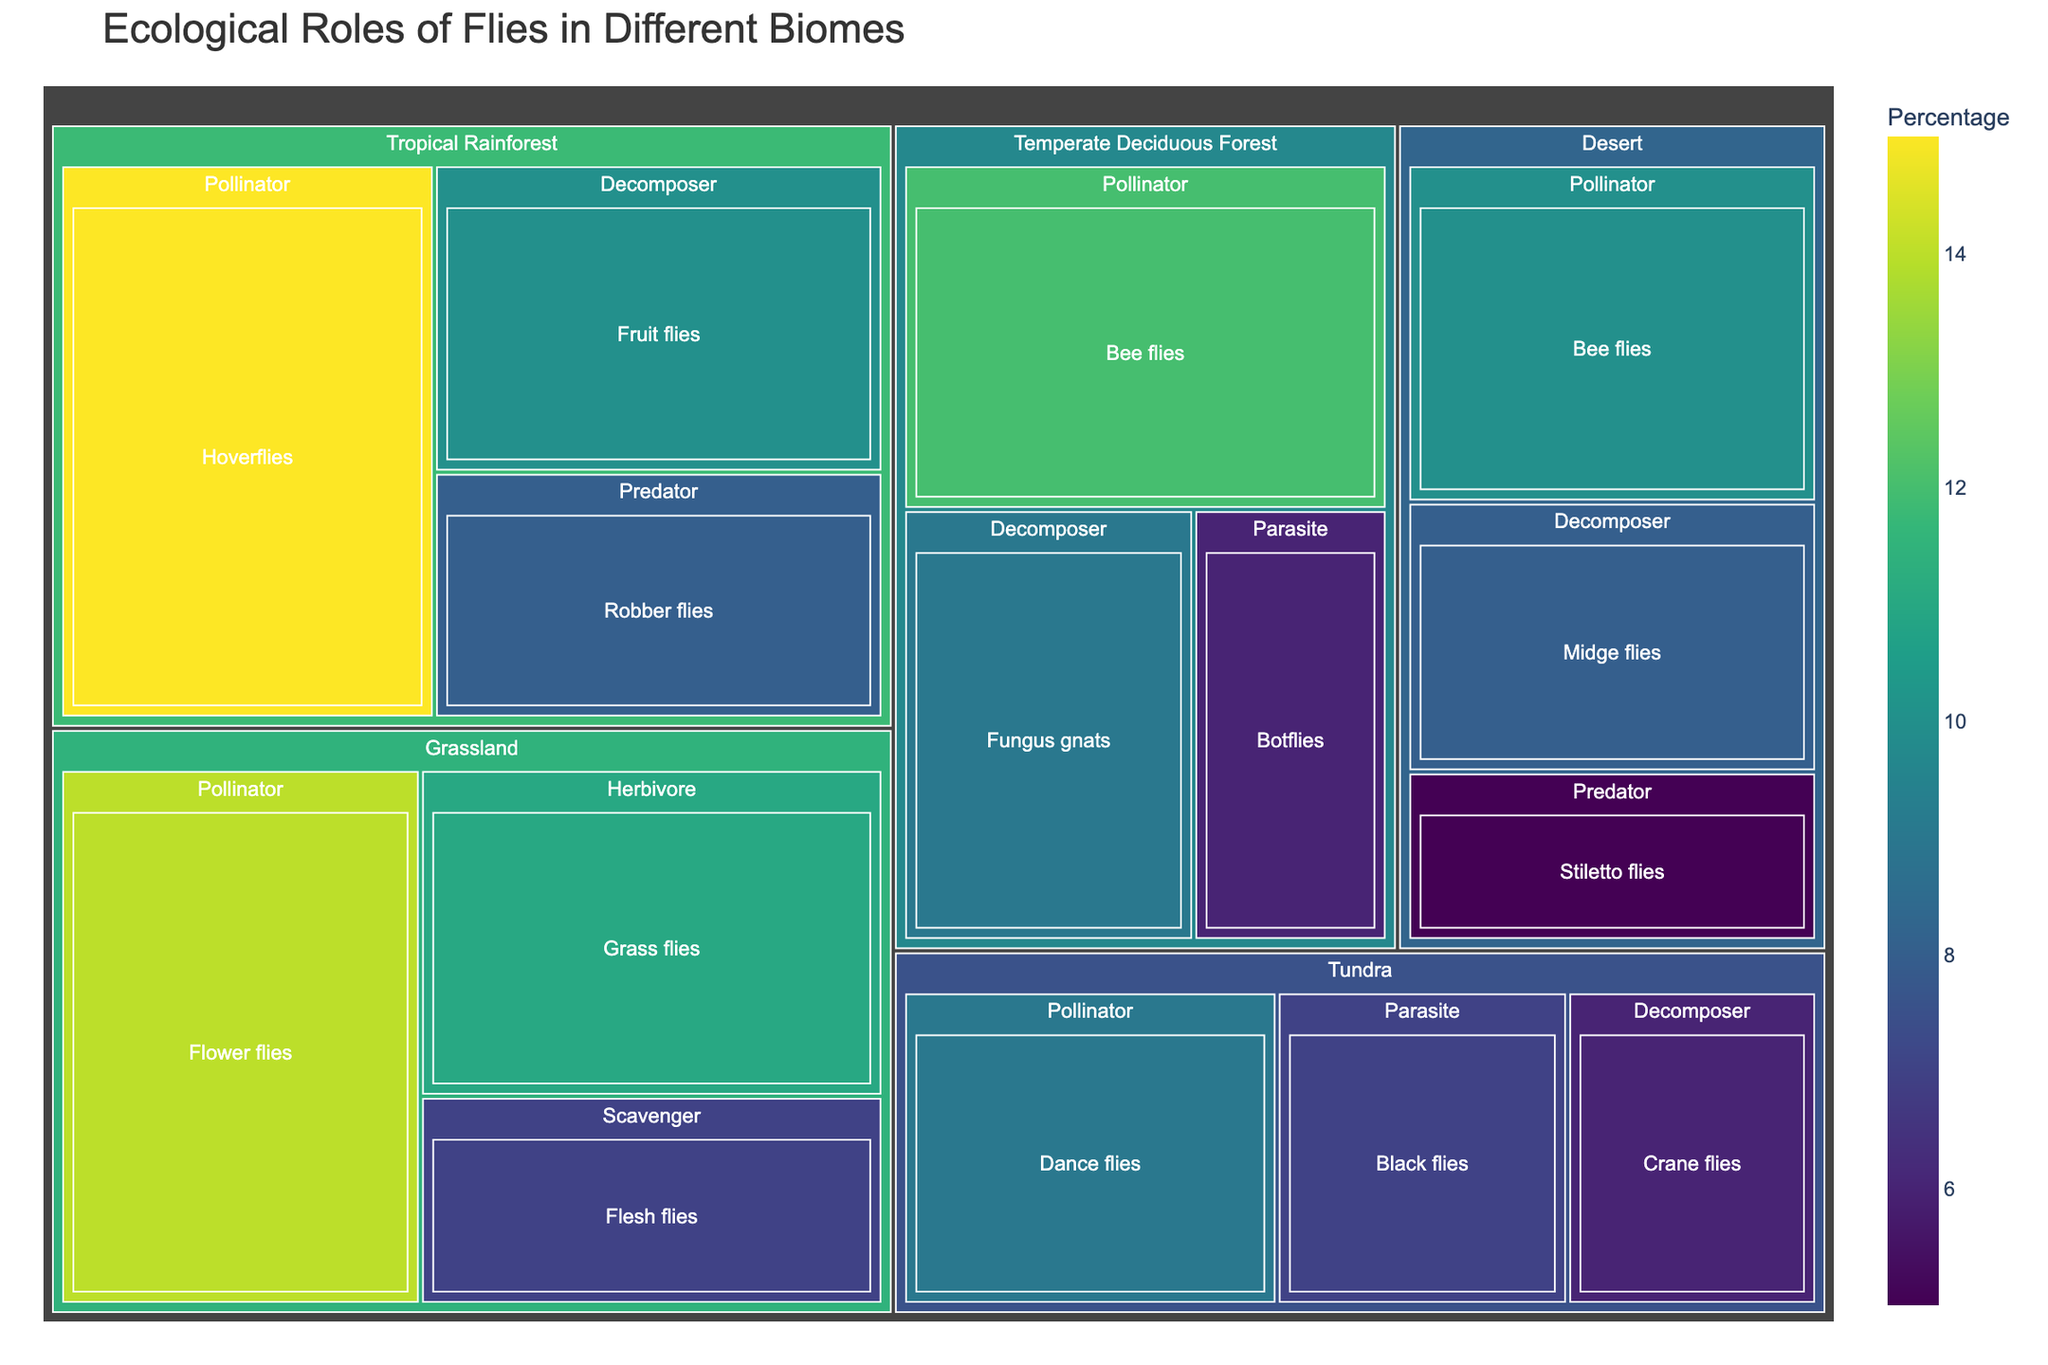What is the title of the treemap? The title of the treemap is usually displayed prominently at the top of the figure. It indicates the subject of the visualization.
Answer: Ecological Roles of Flies in Different Biomes Which biome contributes the most to the role of Pollinators? To determine the biome that contributes the most to Pollinators, look at the size and percentage values of the Pollinator sections within each biome in the treemap.
Answer: Tropical Rainforest What is the combined percentage of decomposer flies in Tropical Rainforest and Desert biomes? Add the percentage values for the decomposer flies in both the Tropical Rainforest and Desert biomes. For Tropical Rainforest: 10%. For Desert: 8%. The combined percentage is 10% + 8% = 18%.
Answer: 18% Which biome has the smallest representation for the role of Predator? Compare the Predator sections across different biomes and identify the one with the smallest size or percentage value.
Answer: Desert What is the percentage difference between Pollinator flies in Grassland and Tundra biomes? Calculate the difference by subtracting the percentage of Pollinator flies in Tundra from that in Grassland. For Grassland: 14%, for Tundra: 9%. The difference is 14% - 9% = 5%.
Answer: 5% Identify the species with the largest representational percentage in the Pollinator role. Look at the percentage values for the Pollinator role across all biomes and find the species with the highest percentage.
Answer: Hoverflies How many unique roles are represented in the Temperate Deciduous Forest biome? Count the different roles under the Temperate Deciduous Forest biome section. The roles are Pollinator, Decomposer, and Parasite.
Answer: 3 What is the average percentage representation of decomposers across all biomes? Sum the percentage values for decomposers across all biomes and divide by the number of biomes. Tropical Rainforest: 10%, Temperate Deciduous Forest: 9%, Desert: 8%, Tundra: 6%. The average is (10% + 9% + 8% + 6%) / 4 = 8.25%.
Answer: 8.25% Which species category within the Tundra biome has the greatest percentage representation? Look at the percentage values within the Tundra biome and identify the species with the highest value.
Answer: Dance flies Aggregate the percentage values of all pollinator species across all biomes. What is the total percentage? Add the percentage values for the Pollinator species in each biome. Tropical Rainforest: 15%, Temperate Deciduous Forest: 12%, Grassland: 14%, Desert: 10%, Tundra: 9%. The total is 15% + 12% + 14% + 10% + 9% = 60%.
Answer: 60% 